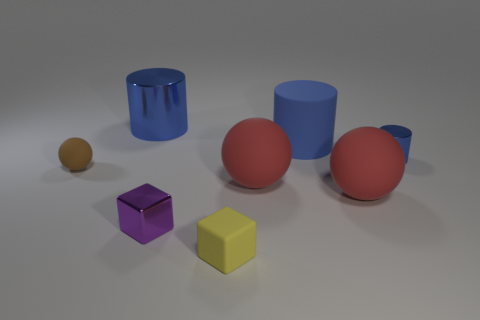How are the objects arranged in terms of depth? The objects are staggered with depth; the brown small sphere is closer to the foreground, followed by the red sphere, purple cube, yellow cube, blue cylinder, and light blue cylinder, in that order. 